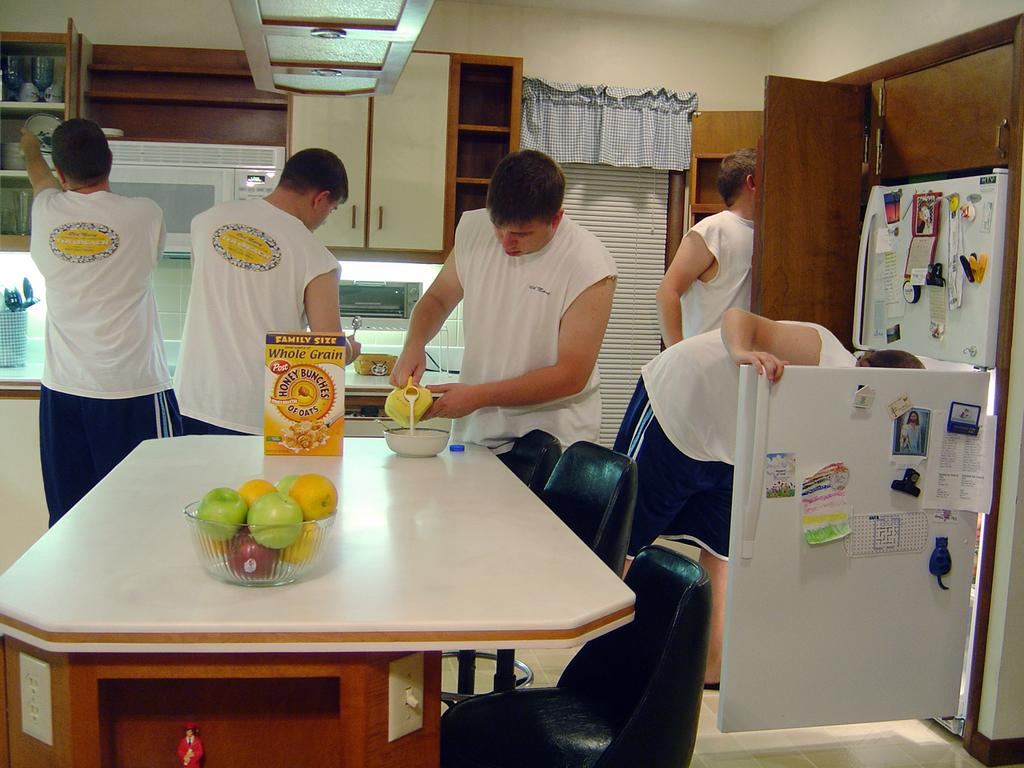Provide a one-sentence caption for the provided image. Five men are in the kitchen working and one in the middle pours milk into the bowl next to the Whole Grain oats. 